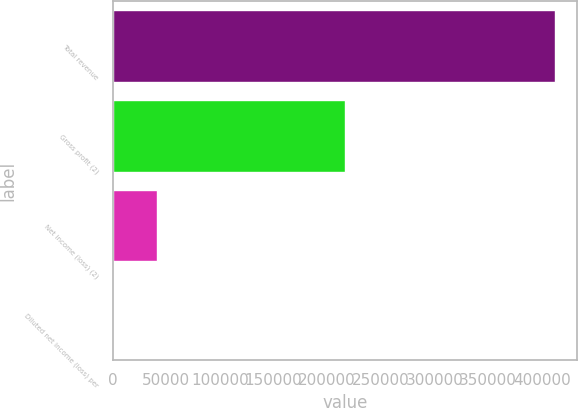Convert chart to OTSL. <chart><loc_0><loc_0><loc_500><loc_500><bar_chart><fcel>Total revenue<fcel>Gross profit (2)<fcel>Net income (loss) (2)<fcel>Diluted net income (loss) per<nl><fcel>412448<fcel>216445<fcel>41244.9<fcel>0.1<nl></chart> 